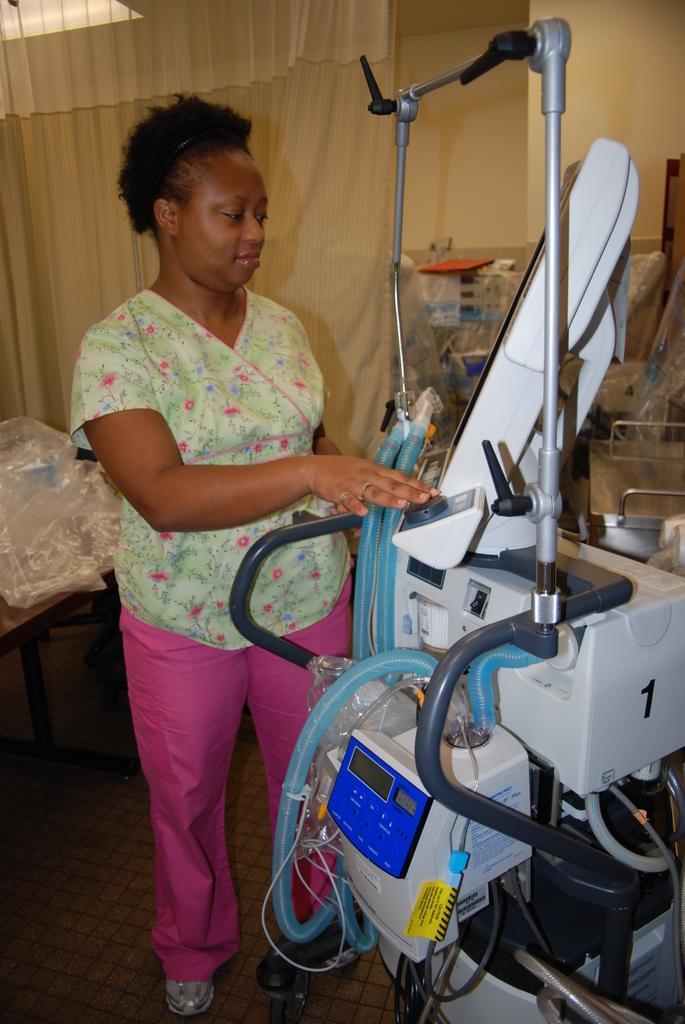Please provide a concise description of this image. In this image I can see a women is standing, I can see she is wearing green colour top and pink colour pant. On the right side of this image I can see a machine and in the background I can see a curtain. 